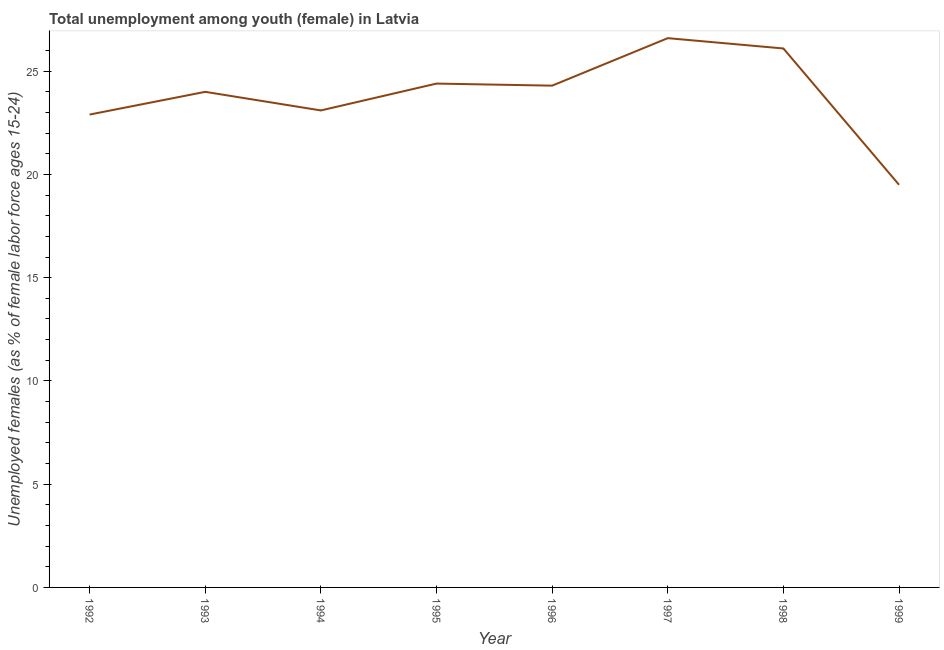What is the unemployed female youth population in 1999?
Your answer should be compact. 19.5. Across all years, what is the maximum unemployed female youth population?
Give a very brief answer. 26.6. Across all years, what is the minimum unemployed female youth population?
Ensure brevity in your answer.  19.5. In which year was the unemployed female youth population maximum?
Ensure brevity in your answer.  1997. In which year was the unemployed female youth population minimum?
Make the answer very short. 1999. What is the sum of the unemployed female youth population?
Keep it short and to the point. 190.9. What is the difference between the unemployed female youth population in 1994 and 1995?
Your response must be concise. -1.3. What is the average unemployed female youth population per year?
Keep it short and to the point. 23.86. What is the median unemployed female youth population?
Keep it short and to the point. 24.15. In how many years, is the unemployed female youth population greater than 19 %?
Provide a succinct answer. 8. Do a majority of the years between 1994 and 1997 (inclusive) have unemployed female youth population greater than 7 %?
Keep it short and to the point. Yes. What is the ratio of the unemployed female youth population in 1992 to that in 1998?
Your response must be concise. 0.88. Is the unemployed female youth population in 1997 less than that in 1999?
Offer a terse response. No. Is the difference between the unemployed female youth population in 1992 and 1998 greater than the difference between any two years?
Ensure brevity in your answer.  No. What is the difference between the highest and the lowest unemployed female youth population?
Keep it short and to the point. 7.1. In how many years, is the unemployed female youth population greater than the average unemployed female youth population taken over all years?
Offer a very short reply. 5. How many years are there in the graph?
Your answer should be compact. 8. Does the graph contain grids?
Offer a very short reply. No. What is the title of the graph?
Offer a very short reply. Total unemployment among youth (female) in Latvia. What is the label or title of the Y-axis?
Your answer should be very brief. Unemployed females (as % of female labor force ages 15-24). What is the Unemployed females (as % of female labor force ages 15-24) of 1992?
Ensure brevity in your answer.  22.9. What is the Unemployed females (as % of female labor force ages 15-24) of 1994?
Your answer should be very brief. 23.1. What is the Unemployed females (as % of female labor force ages 15-24) in 1995?
Your answer should be compact. 24.4. What is the Unemployed females (as % of female labor force ages 15-24) of 1996?
Offer a very short reply. 24.3. What is the Unemployed females (as % of female labor force ages 15-24) of 1997?
Give a very brief answer. 26.6. What is the Unemployed females (as % of female labor force ages 15-24) in 1998?
Give a very brief answer. 26.1. What is the Unemployed females (as % of female labor force ages 15-24) in 1999?
Ensure brevity in your answer.  19.5. What is the difference between the Unemployed females (as % of female labor force ages 15-24) in 1992 and 1993?
Keep it short and to the point. -1.1. What is the difference between the Unemployed females (as % of female labor force ages 15-24) in 1992 and 1997?
Offer a terse response. -3.7. What is the difference between the Unemployed females (as % of female labor force ages 15-24) in 1992 and 1998?
Provide a succinct answer. -3.2. What is the difference between the Unemployed females (as % of female labor force ages 15-24) in 1993 and 1995?
Ensure brevity in your answer.  -0.4. What is the difference between the Unemployed females (as % of female labor force ages 15-24) in 1993 and 1997?
Ensure brevity in your answer.  -2.6. What is the difference between the Unemployed females (as % of female labor force ages 15-24) in 1993 and 1998?
Give a very brief answer. -2.1. What is the difference between the Unemployed females (as % of female labor force ages 15-24) in 1994 and 1998?
Ensure brevity in your answer.  -3. What is the difference between the Unemployed females (as % of female labor force ages 15-24) in 1995 and 1996?
Offer a terse response. 0.1. What is the difference between the Unemployed females (as % of female labor force ages 15-24) in 1995 and 1998?
Offer a terse response. -1.7. What is the difference between the Unemployed females (as % of female labor force ages 15-24) in 1997 and 1998?
Provide a short and direct response. 0.5. What is the ratio of the Unemployed females (as % of female labor force ages 15-24) in 1992 to that in 1993?
Provide a short and direct response. 0.95. What is the ratio of the Unemployed females (as % of female labor force ages 15-24) in 1992 to that in 1995?
Give a very brief answer. 0.94. What is the ratio of the Unemployed females (as % of female labor force ages 15-24) in 1992 to that in 1996?
Ensure brevity in your answer.  0.94. What is the ratio of the Unemployed females (as % of female labor force ages 15-24) in 1992 to that in 1997?
Keep it short and to the point. 0.86. What is the ratio of the Unemployed females (as % of female labor force ages 15-24) in 1992 to that in 1998?
Give a very brief answer. 0.88. What is the ratio of the Unemployed females (as % of female labor force ages 15-24) in 1992 to that in 1999?
Give a very brief answer. 1.17. What is the ratio of the Unemployed females (as % of female labor force ages 15-24) in 1993 to that in 1994?
Ensure brevity in your answer.  1.04. What is the ratio of the Unemployed females (as % of female labor force ages 15-24) in 1993 to that in 1997?
Provide a short and direct response. 0.9. What is the ratio of the Unemployed females (as % of female labor force ages 15-24) in 1993 to that in 1999?
Provide a short and direct response. 1.23. What is the ratio of the Unemployed females (as % of female labor force ages 15-24) in 1994 to that in 1995?
Offer a very short reply. 0.95. What is the ratio of the Unemployed females (as % of female labor force ages 15-24) in 1994 to that in 1996?
Make the answer very short. 0.95. What is the ratio of the Unemployed females (as % of female labor force ages 15-24) in 1994 to that in 1997?
Ensure brevity in your answer.  0.87. What is the ratio of the Unemployed females (as % of female labor force ages 15-24) in 1994 to that in 1998?
Offer a terse response. 0.89. What is the ratio of the Unemployed females (as % of female labor force ages 15-24) in 1994 to that in 1999?
Keep it short and to the point. 1.19. What is the ratio of the Unemployed females (as % of female labor force ages 15-24) in 1995 to that in 1997?
Offer a very short reply. 0.92. What is the ratio of the Unemployed females (as % of female labor force ages 15-24) in 1995 to that in 1998?
Offer a very short reply. 0.94. What is the ratio of the Unemployed females (as % of female labor force ages 15-24) in 1995 to that in 1999?
Your answer should be compact. 1.25. What is the ratio of the Unemployed females (as % of female labor force ages 15-24) in 1996 to that in 1997?
Offer a very short reply. 0.91. What is the ratio of the Unemployed females (as % of female labor force ages 15-24) in 1996 to that in 1998?
Provide a succinct answer. 0.93. What is the ratio of the Unemployed females (as % of female labor force ages 15-24) in 1996 to that in 1999?
Make the answer very short. 1.25. What is the ratio of the Unemployed females (as % of female labor force ages 15-24) in 1997 to that in 1998?
Give a very brief answer. 1.02. What is the ratio of the Unemployed females (as % of female labor force ages 15-24) in 1997 to that in 1999?
Offer a very short reply. 1.36. What is the ratio of the Unemployed females (as % of female labor force ages 15-24) in 1998 to that in 1999?
Ensure brevity in your answer.  1.34. 